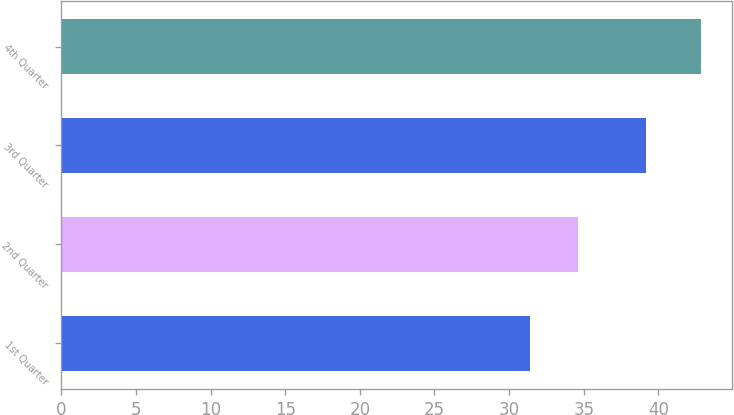<chart> <loc_0><loc_0><loc_500><loc_500><bar_chart><fcel>1st Quarter<fcel>2nd Quarter<fcel>3rd Quarter<fcel>4th Quarter<nl><fcel>31.41<fcel>34.58<fcel>39.2<fcel>42.82<nl></chart> 